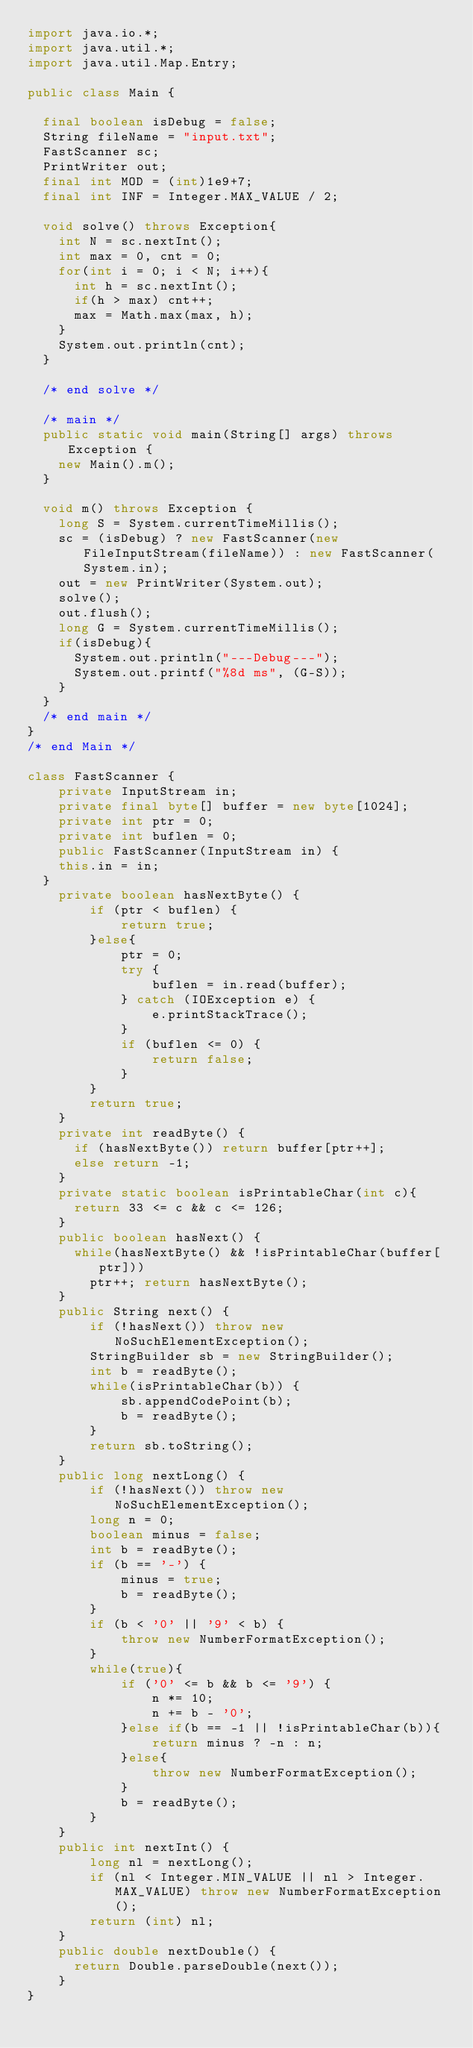<code> <loc_0><loc_0><loc_500><loc_500><_Java_>import java.io.*;
import java.util.*;
import java.util.Map.Entry;

public class Main {
	
	final boolean isDebug = false;
	String fileName = "input.txt";
	FastScanner sc;
	PrintWriter out;
	final int MOD = (int)1e9+7;
	final int INF = Integer.MAX_VALUE / 2;
	
	void solve() throws Exception{
		int N = sc.nextInt();
		int max = 0, cnt = 0;
		for(int i = 0; i < N; i++){
			int h = sc.nextInt();
			if(h > max) cnt++;
			max = Math.max(max, h);
		}
		System.out.println(cnt);
	}
	
	/* end solve */
	
	/* main */
	public static void main(String[] args) throws Exception {
		new Main().m();
	}
	
	void m() throws Exception {
		long S = System.currentTimeMillis();
		sc = (isDebug) ? new FastScanner(new FileInputStream(fileName)) : new FastScanner(System.in);
		out = new PrintWriter(System.out);
		solve();
		out.flush();
		long G = System.currentTimeMillis();
		if(isDebug){
			System.out.println("---Debug---");
			System.out.printf("%8d ms", (G-S));
		}
	}
	/* end main */
}
/* end Main */

class FastScanner {
    private InputStream in;
    private final byte[] buffer = new byte[1024];
    private int ptr = 0;
    private int buflen = 0;
    public FastScanner(InputStream in) {
		this.in = in;
	}
    private boolean hasNextByte() {
        if (ptr < buflen) {
            return true;
        }else{
            ptr = 0;
            try {
                buflen = in.read(buffer);
            } catch (IOException e) {
                e.printStackTrace();
            }
            if (buflen <= 0) {
                return false;
            }
        }
        return true;
    }
    private int readByte() {
    	if (hasNextByte()) return buffer[ptr++];
    	else return -1;
    }
    private static boolean isPrintableChar(int c){
    	return 33 <= c && c <= 126;
    }
    public boolean hasNext() {
    	while(hasNextByte() && !isPrintableChar(buffer[ptr]))
    		ptr++; return hasNextByte();
    }
    public String next() {
        if (!hasNext()) throw new NoSuchElementException();
        StringBuilder sb = new StringBuilder();
        int b = readByte();
        while(isPrintableChar(b)) {
            sb.appendCodePoint(b);
            b = readByte();
        }
        return sb.toString();
    }
    public long nextLong() {
        if (!hasNext()) throw new NoSuchElementException();
        long n = 0;
        boolean minus = false;
        int b = readByte();
        if (b == '-') {
            minus = true;
            b = readByte();
        }
        if (b < '0' || '9' < b) {
            throw new NumberFormatException();
        }
        while(true){
            if ('0' <= b && b <= '9') {
                n *= 10;
                n += b - '0';
            }else if(b == -1 || !isPrintableChar(b)){
                return minus ? -n : n;
            }else{
                throw new NumberFormatException();
            }
            b = readByte();
        }
    }
    public int nextInt() {
        long nl = nextLong();
        if (nl < Integer.MIN_VALUE || nl > Integer.MAX_VALUE) throw new NumberFormatException();
        return (int) nl;
    }
    public double nextDouble() {
    	return Double.parseDouble(next());
    }
}</code> 